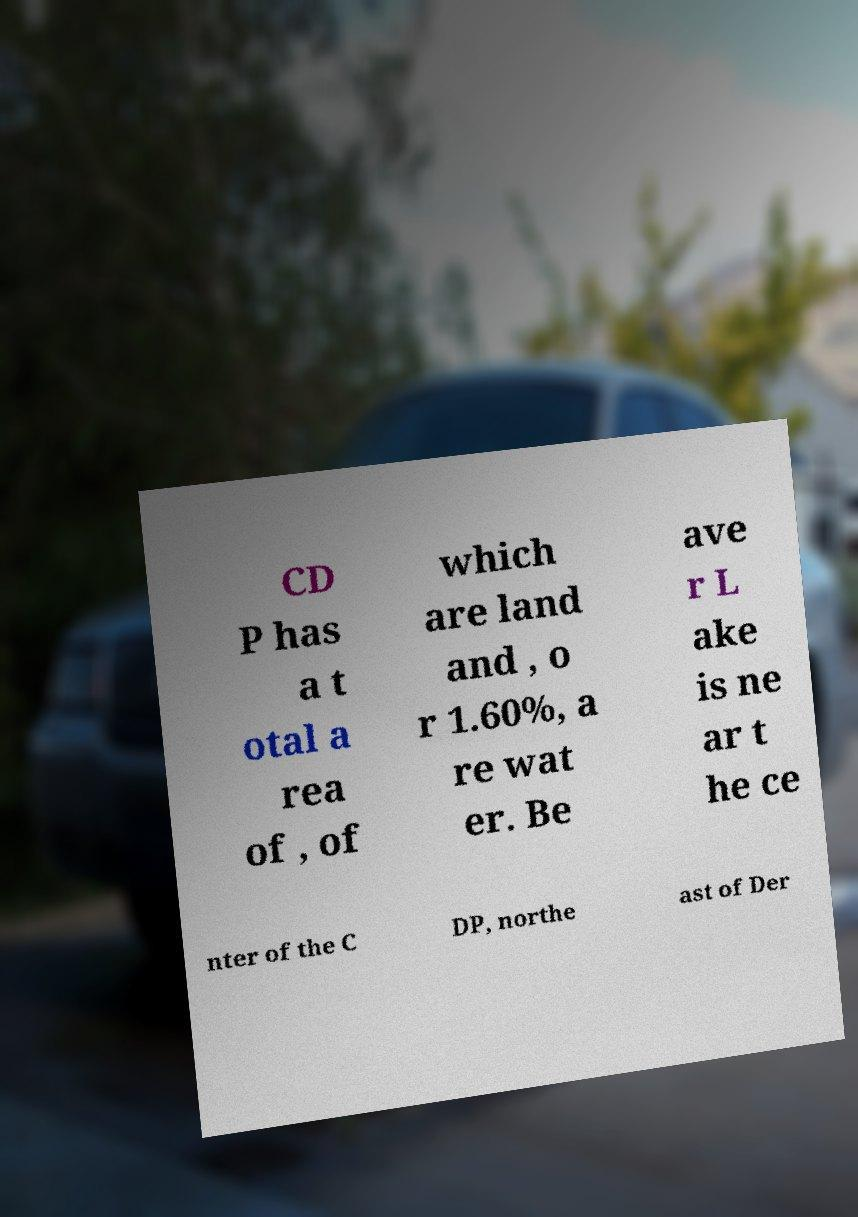Can you accurately transcribe the text from the provided image for me? CD P has a t otal a rea of , of which are land and , o r 1.60%, a re wat er. Be ave r L ake is ne ar t he ce nter of the C DP, northe ast of Der 